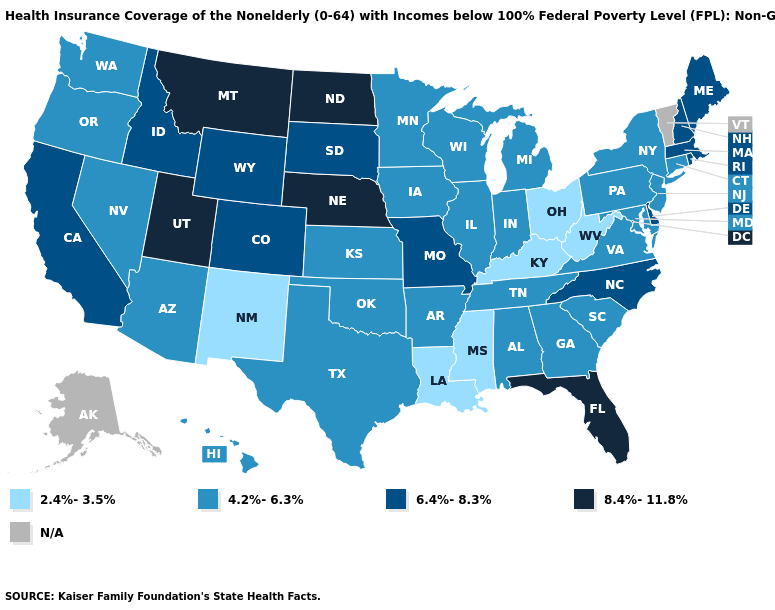What is the value of New York?
Be succinct. 4.2%-6.3%. Does North Carolina have the lowest value in the USA?
Write a very short answer. No. What is the highest value in states that border Oregon?
Quick response, please. 6.4%-8.3%. Name the states that have a value in the range 8.4%-11.8%?
Keep it brief. Florida, Montana, Nebraska, North Dakota, Utah. Does the first symbol in the legend represent the smallest category?
Concise answer only. Yes. What is the value of Kansas?
Short answer required. 4.2%-6.3%. What is the highest value in states that border Illinois?
Quick response, please. 6.4%-8.3%. Does Missouri have the lowest value in the MidWest?
Be succinct. No. Does Ohio have the lowest value in the USA?
Give a very brief answer. Yes. Does Louisiana have the lowest value in the USA?
Write a very short answer. Yes. What is the value of New Jersey?
Give a very brief answer. 4.2%-6.3%. What is the highest value in states that border Kansas?
Short answer required. 8.4%-11.8%. What is the value of Utah?
Quick response, please. 8.4%-11.8%. What is the lowest value in the MidWest?
Write a very short answer. 2.4%-3.5%. What is the highest value in states that border Maine?
Short answer required. 6.4%-8.3%. 